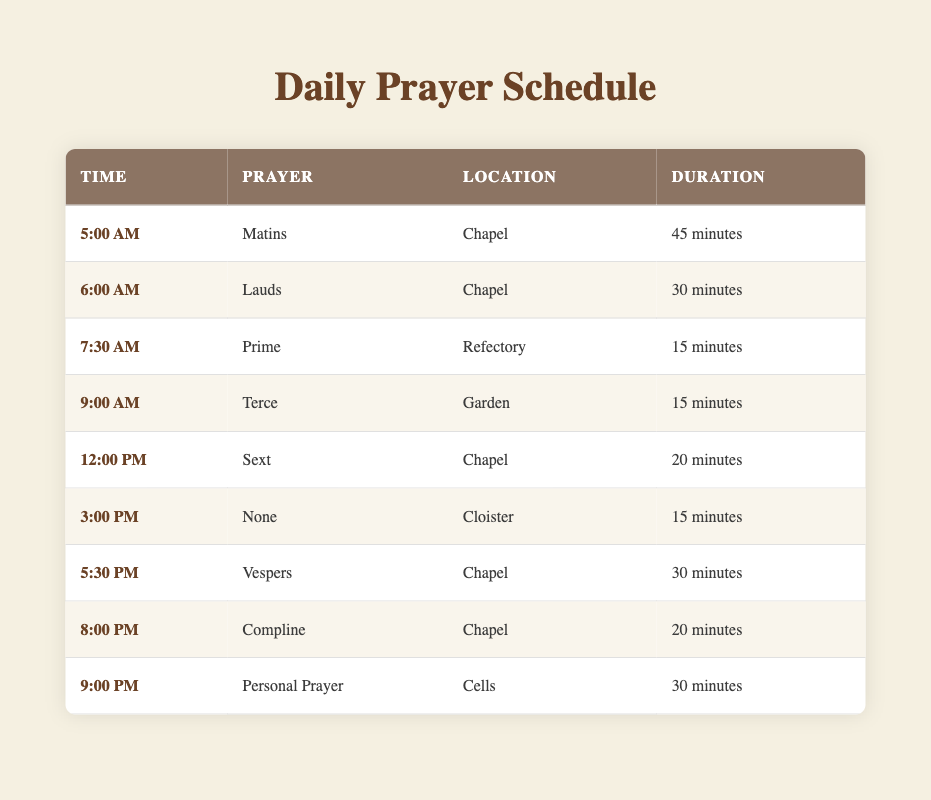What time is Matins held? The table lists the time for each prayer. The row for Matins indicates that it is held at 5:00 AM.
Answer: 5:00 AM How long is Vespers? By checking the duration column for Vespers, we see that it is listed as 30 minutes.
Answer: 30 minutes Is Terce held in the Cloister? The table shows that Terce takes place in the Garden, not the Cloister. Therefore, the answer is no.
Answer: No What is the total duration of prayer from 5:00 AM to 12:00 PM? To find the total duration, we look at the durations from Matins (45 minutes), Lauds (30 minutes), Prime (15 minutes), and Sext (20 minutes). Adding these gives: 45 + 30 + 15 + 20 = 110 minutes.
Answer: 110 minutes How many prayers take place in the Chapel? By counting the rows where the location is Chapel, we find that Matins, Lauds, Sext, Vespers, and Compline are all held there. This totals to five prayers.
Answer: 5 What is the duration difference between Compline and Personal Prayer? Compline is listed as 20 minutes and Personal Prayer as 30 minutes. The difference is 30 - 20 = 10 minutes.
Answer: 10 minutes Which prayer occurs last in the day? Scanning through the times in the table, we see the last prayer is Personal Prayer at 9:00 PM.
Answer: Personal Prayer How many prayers are held before noon? By looking at the schedule, we find that there are four prayers (Matins, Lauds, Prime, Sext) before noon.
Answer: 4 Is there a prayer in the Garden? The table clearly shows that Terce takes place in the Garden. Therefore, the answer is yes.
Answer: Yes 